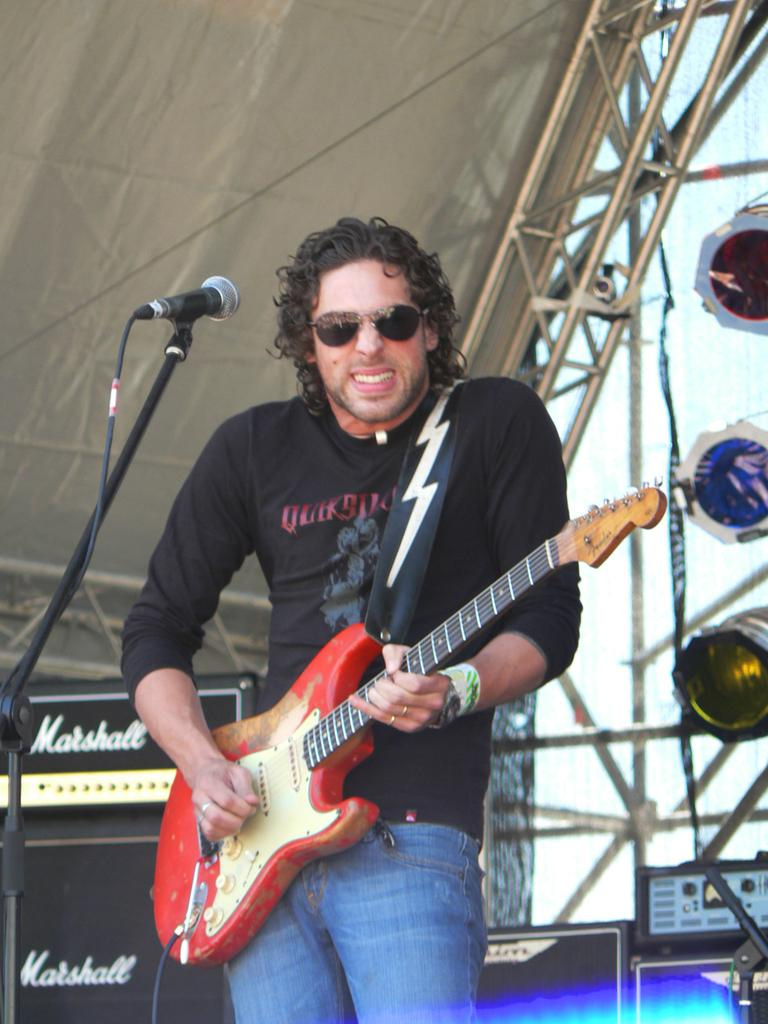What is the main subject of the image? There is a man in the image. What is the man doing in the image? The man is standing and holding a guitar with his hands. What object is associated with the man's activity in the image? There is a microphone in the image. What is the man wearing in the image? The man is wearing a black T-shirt. Can you describe the quilt that the man is using to cover the club in the image? There is no quilt or club present in the image. The man is holding a guitar and standing near a microphone, wearing a black T-shirt. How does the earthquake affect the man's performance in the image? There is no earthquake present in the image. The man is standing and holding a guitar with his hands, wearing a black T-shirt. 